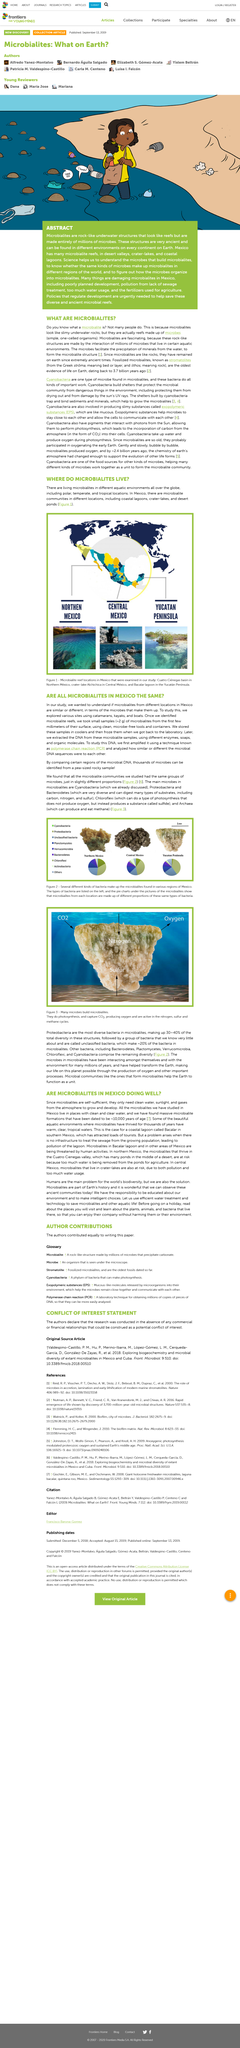Indicate a few pertinent items in this graphic. Lithos, the Greek word for rock, is a term that embodies the essence of the brand's commitment to providing high-quality audio products that are built to withstand the test of time, just like a solid rock. The main microbes found in microbialities are Cyanobacteria, Proteobacteria, Bacteroidetes, Chloroflexi, and Archaea. Microbialites are formed by the activity of microbes, which do photosynthesis and capture CO2 to produce oxygen as a byproduct. Figure 2 contains a list of various bacteria that make up the microbialities in different regions of Mexico, as well as several different kinds of bacteria. Cyanobacteria is a type of microbe that can be found in microbialites. 